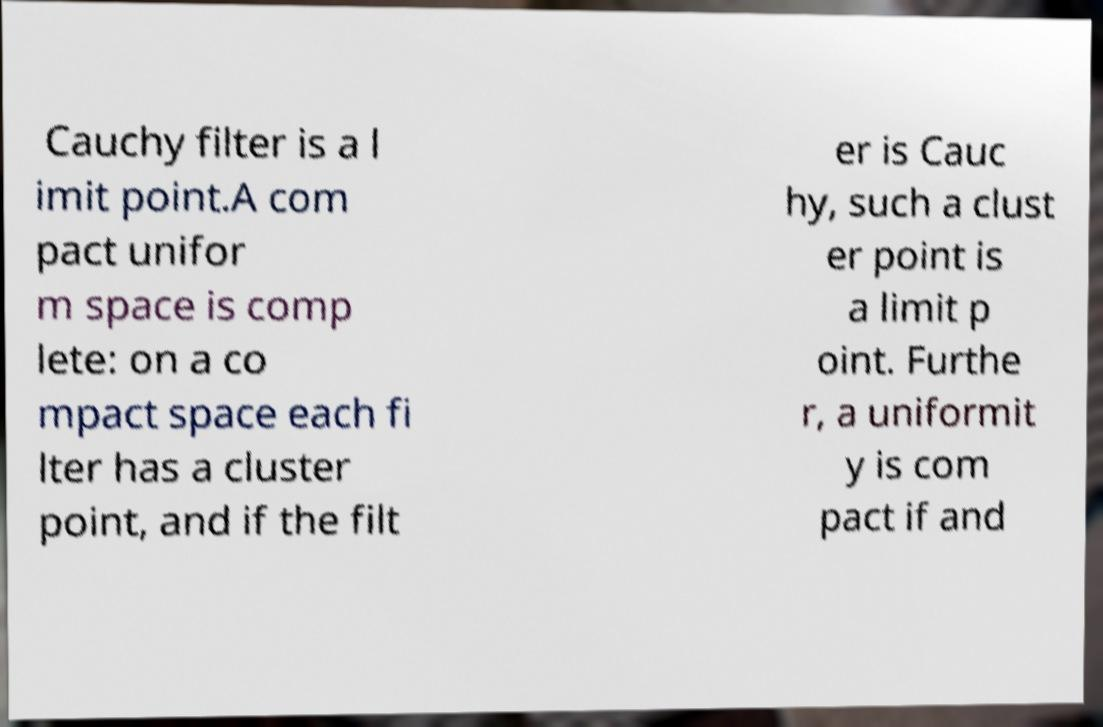What messages or text are displayed in this image? I need them in a readable, typed format. Cauchy filter is a l imit point.A com pact unifor m space is comp lete: on a co mpact space each fi lter has a cluster point, and if the filt er is Cauc hy, such a clust er point is a limit p oint. Furthe r, a uniformit y is com pact if and 